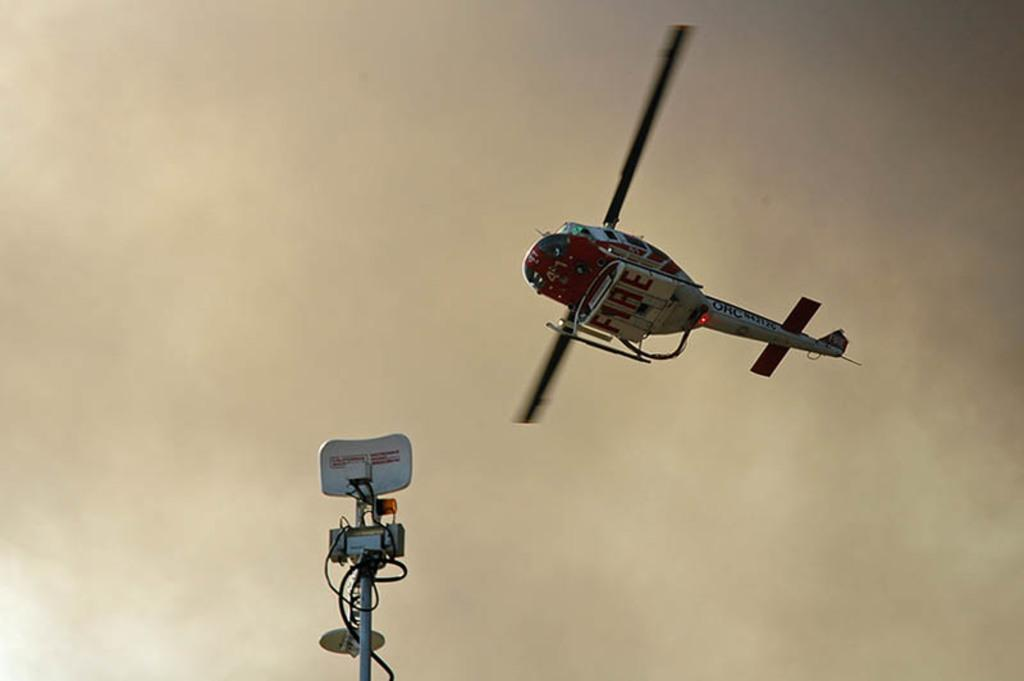<image>
Share a concise interpretation of the image provided. A red and white Helicopter with the word FIRE written on the bottom of it flying through some hazy smoke. 